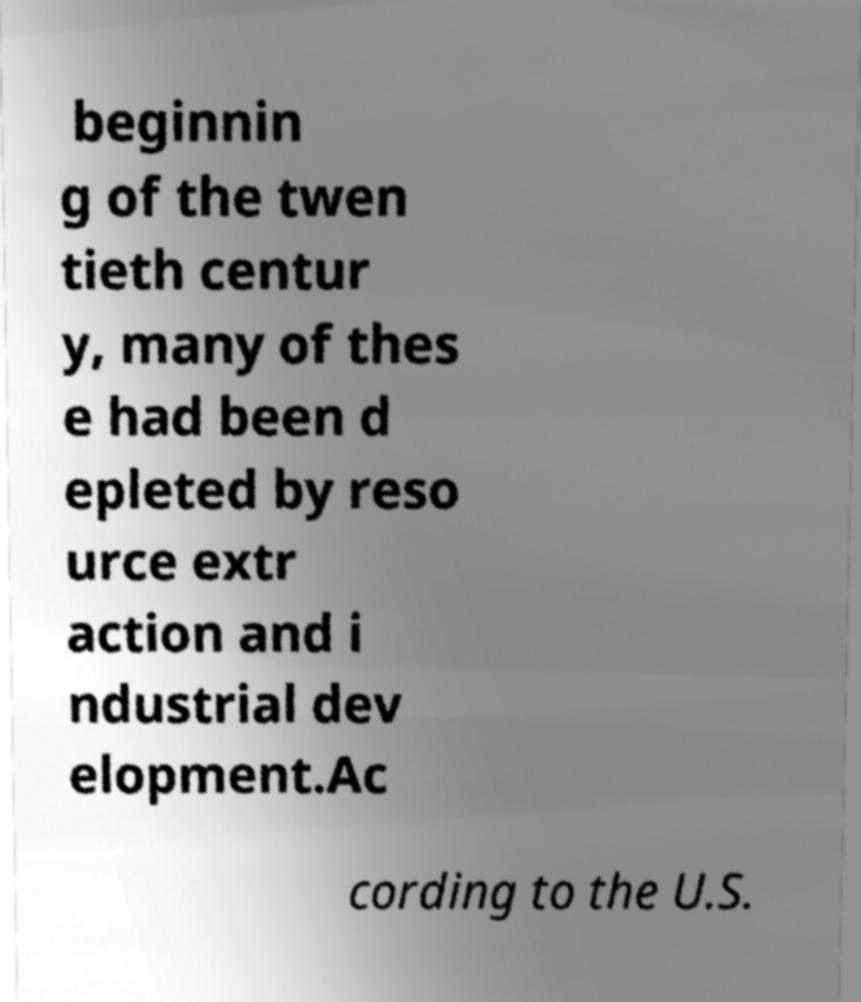Please identify and transcribe the text found in this image. beginnin g of the twen tieth centur y, many of thes e had been d epleted by reso urce extr action and i ndustrial dev elopment.Ac cording to the U.S. 